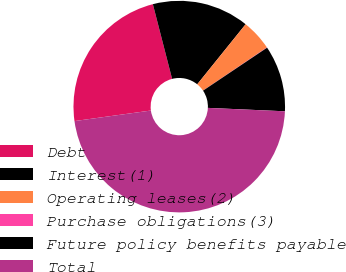<chart> <loc_0><loc_0><loc_500><loc_500><pie_chart><fcel>Debt<fcel>Interest(1)<fcel>Operating leases(2)<fcel>Purchase obligations(3)<fcel>Future policy benefits payable<fcel>Total<nl><fcel>23.17%<fcel>14.81%<fcel>4.75%<fcel>0.05%<fcel>10.11%<fcel>47.11%<nl></chart> 